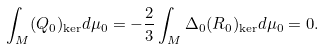Convert formula to latex. <formula><loc_0><loc_0><loc_500><loc_500>\int _ { M } ( Q _ { 0 } ) _ { \ker } d \mu _ { 0 } = - \frac { 2 } { 3 } \int _ { M } \Delta _ { 0 } ( R _ { 0 } ) _ { \ker } d \mu _ { 0 } = 0 .</formula> 